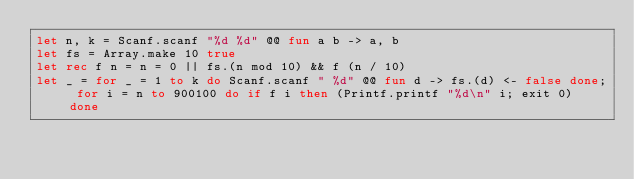<code> <loc_0><loc_0><loc_500><loc_500><_OCaml_>let n, k = Scanf.scanf "%d %d" @@ fun a b -> a, b
let fs = Array.make 10 true
let rec f n = n = 0 || fs.(n mod 10) && f (n / 10)
let _ = for _ = 1 to k do Scanf.scanf " %d" @@ fun d -> fs.(d) <- false done; for i = n to 900100 do if f i then (Printf.printf "%d\n" i; exit 0) done</code> 